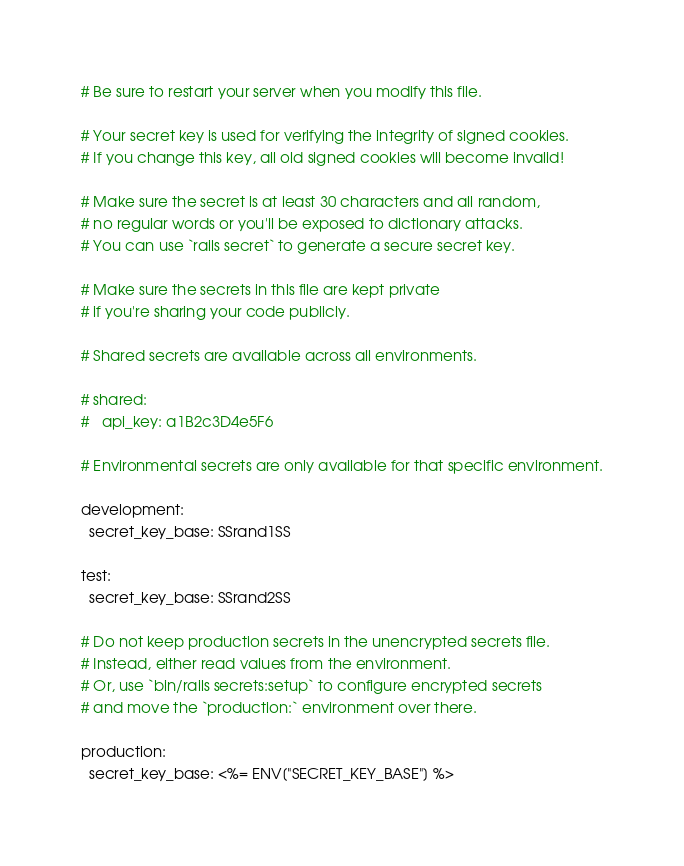Convert code to text. <code><loc_0><loc_0><loc_500><loc_500><_YAML_># Be sure to restart your server when you modify this file.

# Your secret key is used for verifying the integrity of signed cookies.
# If you change this key, all old signed cookies will become invalid!

# Make sure the secret is at least 30 characters and all random,
# no regular words or you'll be exposed to dictionary attacks.
# You can use `rails secret` to generate a secure secret key.

# Make sure the secrets in this file are kept private
# if you're sharing your code publicly.

# Shared secrets are available across all environments.

# shared:
#   api_key: a1B2c3D4e5F6

# Environmental secrets are only available for that specific environment.

development:
  secret_key_base: SSrand1SS

test:
  secret_key_base: SSrand2SS

# Do not keep production secrets in the unencrypted secrets file.
# Instead, either read values from the environment.
# Or, use `bin/rails secrets:setup` to configure encrypted secrets
# and move the `production:` environment over there.

production:
  secret_key_base: <%= ENV["SECRET_KEY_BASE"] %>
</code> 